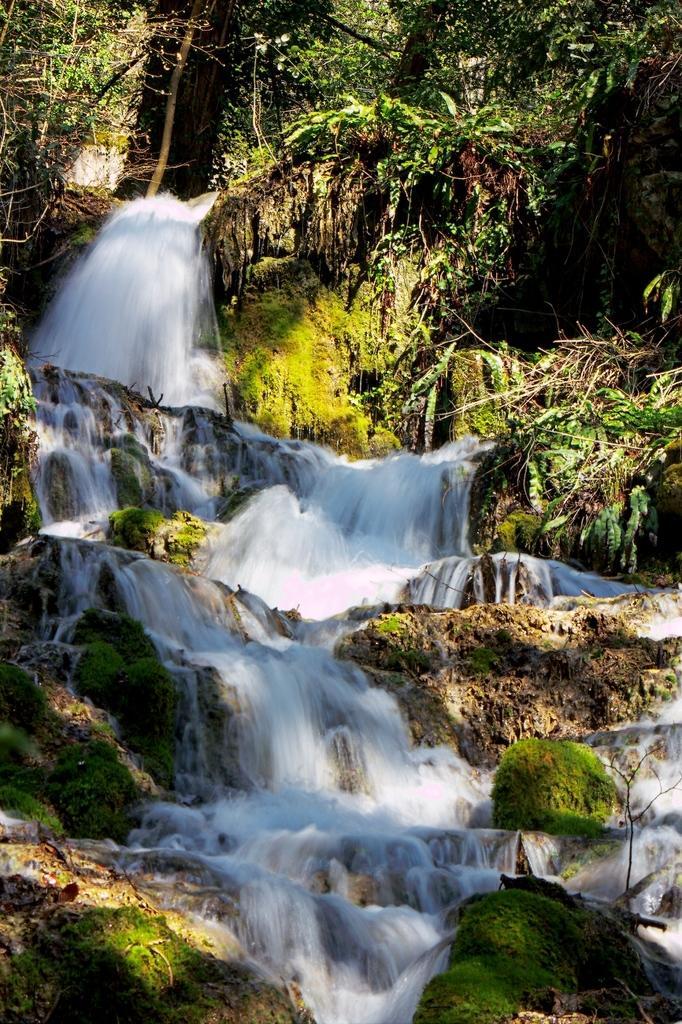Can you describe this image briefly? In this image we can see waterfall. Also there are trees and plants. 